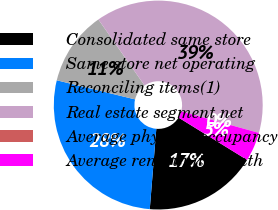Convert chart. <chart><loc_0><loc_0><loc_500><loc_500><pie_chart><fcel>Consolidated same store<fcel>Same store net operating<fcel>Reconciling items(1)<fcel>Real estate segment net<fcel>Average physical occupancy<fcel>Average rent/unit/month<nl><fcel>17.49%<fcel>27.52%<fcel>11.48%<fcel>39.0%<fcel>0.01%<fcel>4.51%<nl></chart> 